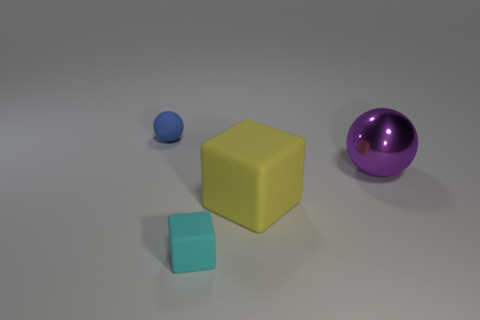Add 3 small rubber objects. How many objects exist? 7 Subtract all cyan cubes. Subtract all green cylinders. How many cubes are left? 1 Subtract all purple spheres. How many blue blocks are left? 0 Subtract all large red shiny cylinders. Subtract all purple metallic balls. How many objects are left? 3 Add 1 big shiny balls. How many big shiny balls are left? 2 Add 4 large blocks. How many large blocks exist? 5 Subtract all cyan blocks. How many blocks are left? 1 Subtract 0 cyan balls. How many objects are left? 4 Subtract 1 spheres. How many spheres are left? 1 